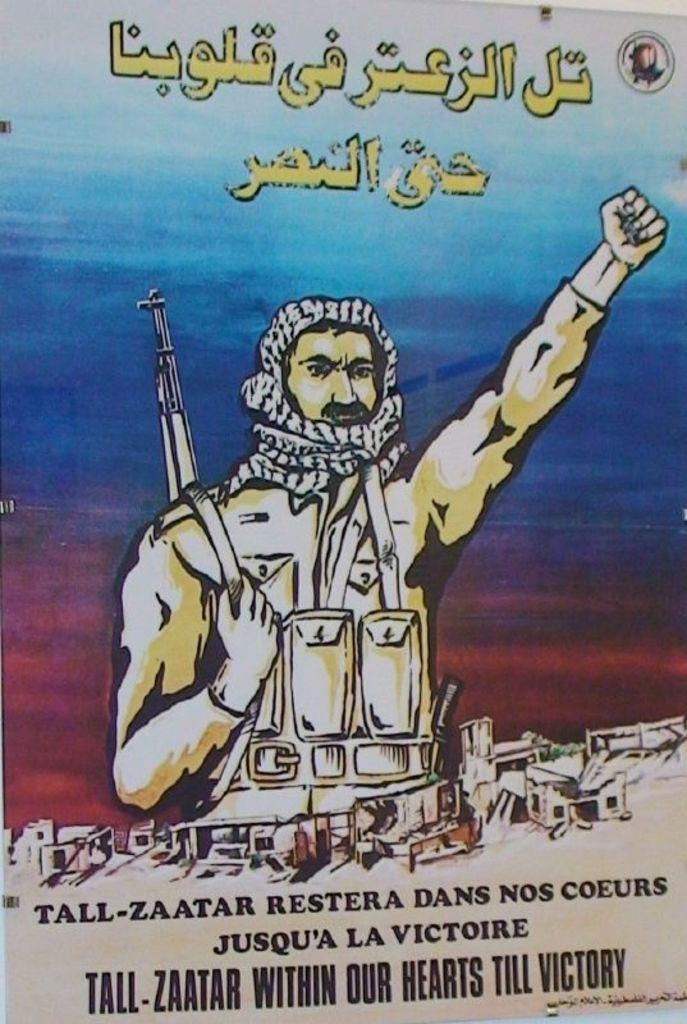<image>
Share a concise interpretation of the image provided. A man hold his arm up over words that spellJusqu'a La Victire. 